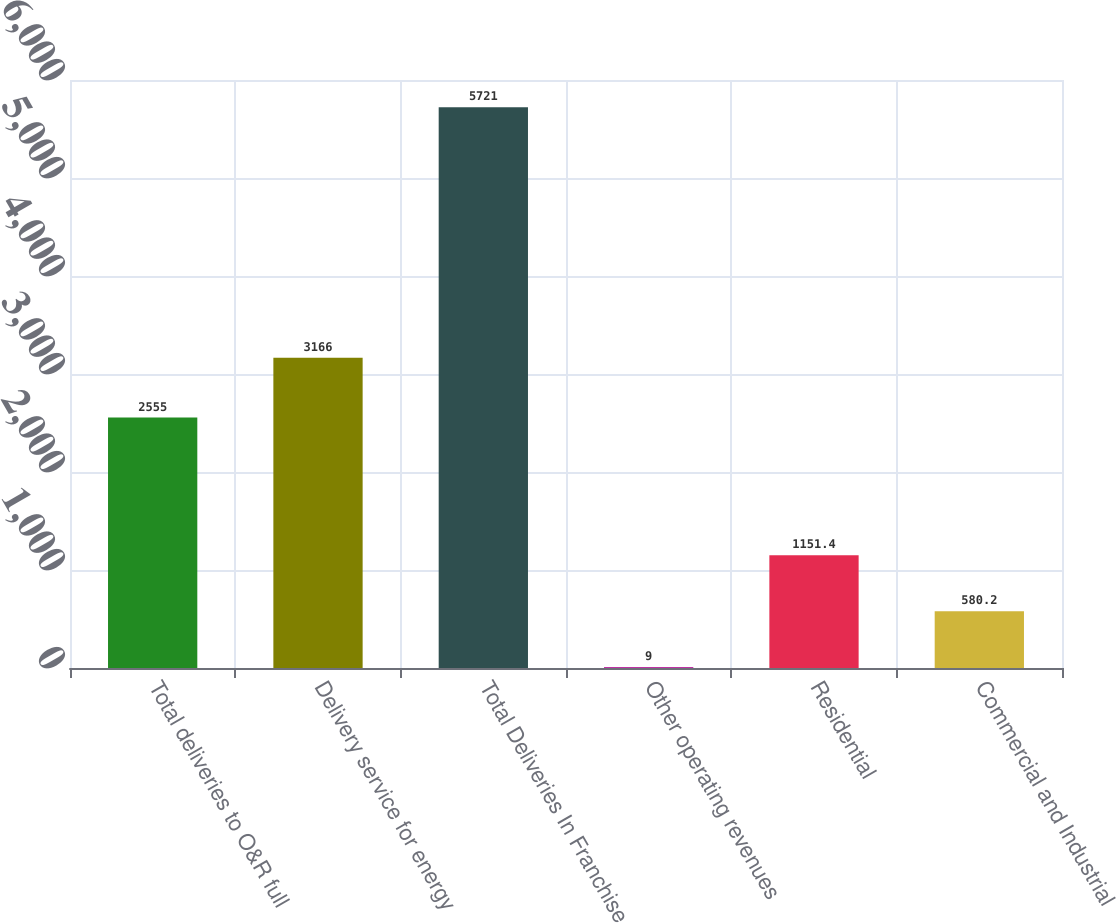Convert chart to OTSL. <chart><loc_0><loc_0><loc_500><loc_500><bar_chart><fcel>Total deliveries to O&R full<fcel>Delivery service for energy<fcel>Total Deliveries In Franchise<fcel>Other operating revenues<fcel>Residential<fcel>Commercial and Industrial<nl><fcel>2555<fcel>3166<fcel>5721<fcel>9<fcel>1151.4<fcel>580.2<nl></chart> 